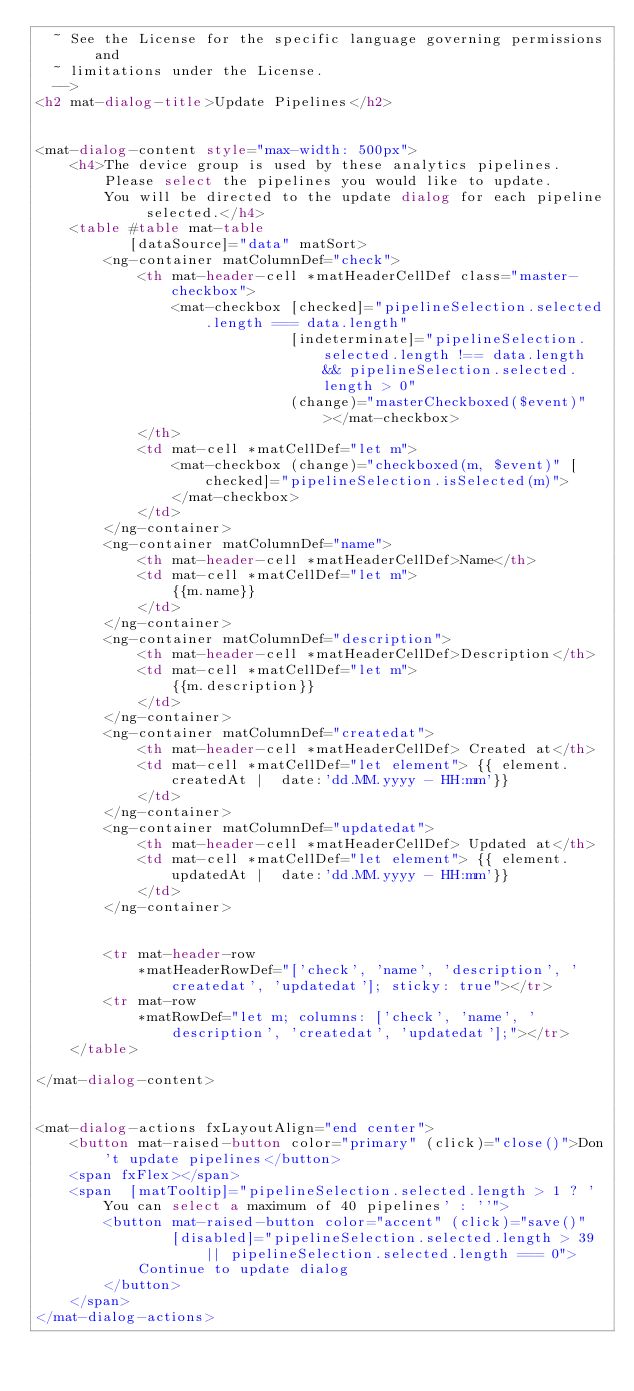<code> <loc_0><loc_0><loc_500><loc_500><_HTML_>  ~ See the License for the specific language governing permissions and
  ~ limitations under the License.
  -->
<h2 mat-dialog-title>Update Pipelines</h2>


<mat-dialog-content style="max-width: 500px">
    <h4>The device group is used by these analytics pipelines.
        Please select the pipelines you would like to update.
        You will be directed to the update dialog for each pipeline selected.</h4>
    <table #table mat-table
           [dataSource]="data" matSort>
        <ng-container matColumnDef="check">
            <th mat-header-cell *matHeaderCellDef class="master-checkbox">
                <mat-checkbox [checked]="pipelineSelection.selected.length === data.length"
                              [indeterminate]="pipelineSelection.selected.length !== data.length && pipelineSelection.selected.length > 0"
                              (change)="masterCheckboxed($event)"></mat-checkbox>
            </th>
            <td mat-cell *matCellDef="let m">
                <mat-checkbox (change)="checkboxed(m, $event)" [checked]="pipelineSelection.isSelected(m)">
                </mat-checkbox>
            </td>
        </ng-container>
        <ng-container matColumnDef="name">
            <th mat-header-cell *matHeaderCellDef>Name</th>
            <td mat-cell *matCellDef="let m">
                {{m.name}}
            </td>
        </ng-container>
        <ng-container matColumnDef="description">
            <th mat-header-cell *matHeaderCellDef>Description</th>
            <td mat-cell *matCellDef="let m">
                {{m.description}}
            </td>
        </ng-container>
        <ng-container matColumnDef="createdat">
            <th mat-header-cell *matHeaderCellDef> Created at</th>
            <td mat-cell *matCellDef="let element"> {{ element.createdAt |  date:'dd.MM.yyyy - HH:mm'}}
            </td>
        </ng-container>
        <ng-container matColumnDef="updatedat">
            <th mat-header-cell *matHeaderCellDef> Updated at</th>
            <td mat-cell *matCellDef="let element"> {{ element.updatedAt |  date:'dd.MM.yyyy - HH:mm'}}
            </td>
        </ng-container>


        <tr mat-header-row
            *matHeaderRowDef="['check', 'name', 'description', 'createdat', 'updatedat']; sticky: true"></tr>
        <tr mat-row
            *matRowDef="let m; columns: ['check', 'name', 'description', 'createdat', 'updatedat'];"></tr>
    </table>

</mat-dialog-content>


<mat-dialog-actions fxLayoutAlign="end center">
    <button mat-raised-button color="primary" (click)="close()">Don't update pipelines</button>
    <span fxFlex></span>
    <span  [matTooltip]="pipelineSelection.selected.length > 1 ? 'You can select a maximum of 40 pipelines' : ''">
        <button mat-raised-button color="accent" (click)="save()"
                [disabled]="pipelineSelection.selected.length > 39 || pipelineSelection.selected.length === 0">
            Continue to update dialog
        </button>
    </span>
</mat-dialog-actions>

</code> 